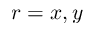Convert formula to latex. <formula><loc_0><loc_0><loc_500><loc_500>r = x , y</formula> 